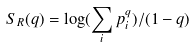<formula> <loc_0><loc_0><loc_500><loc_500>S _ { R } ( q ) = \log ( \sum _ { i } p _ { i } ^ { q } ) / ( 1 - q )</formula> 